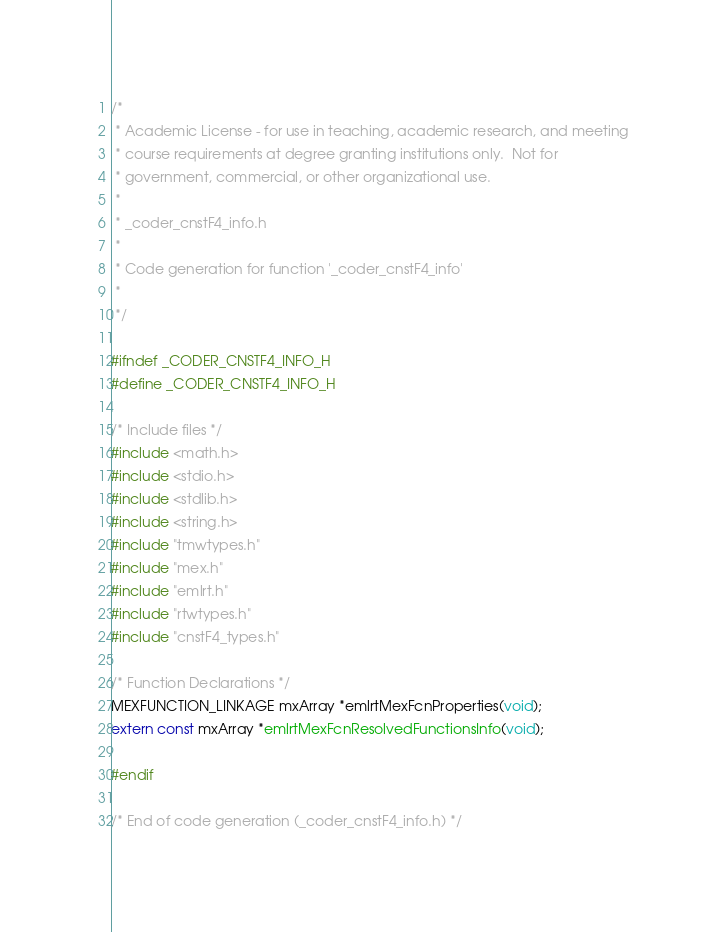Convert code to text. <code><loc_0><loc_0><loc_500><loc_500><_C_>/*
 * Academic License - for use in teaching, academic research, and meeting
 * course requirements at degree granting institutions only.  Not for
 * government, commercial, or other organizational use.
 *
 * _coder_cnstF4_info.h
 *
 * Code generation for function '_coder_cnstF4_info'
 *
 */

#ifndef _CODER_CNSTF4_INFO_H
#define _CODER_CNSTF4_INFO_H

/* Include files */
#include <math.h>
#include <stdio.h>
#include <stdlib.h>
#include <string.h>
#include "tmwtypes.h"
#include "mex.h"
#include "emlrt.h"
#include "rtwtypes.h"
#include "cnstF4_types.h"

/* Function Declarations */
MEXFUNCTION_LINKAGE mxArray *emlrtMexFcnProperties(void);
extern const mxArray *emlrtMexFcnResolvedFunctionsInfo(void);

#endif

/* End of code generation (_coder_cnstF4_info.h) */
</code> 